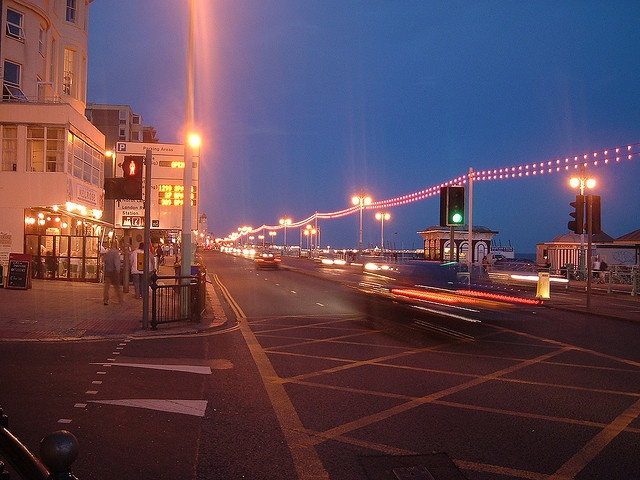Describe the objects in this image and their specific colors. I can see people in black, maroon, and brown tones, traffic light in black, maroon, red, and khaki tones, traffic light in black, gray, darkgreen, and ivory tones, people in black, maroon, brown, and salmon tones, and traffic light in black, maroon, purple, and brown tones in this image. 